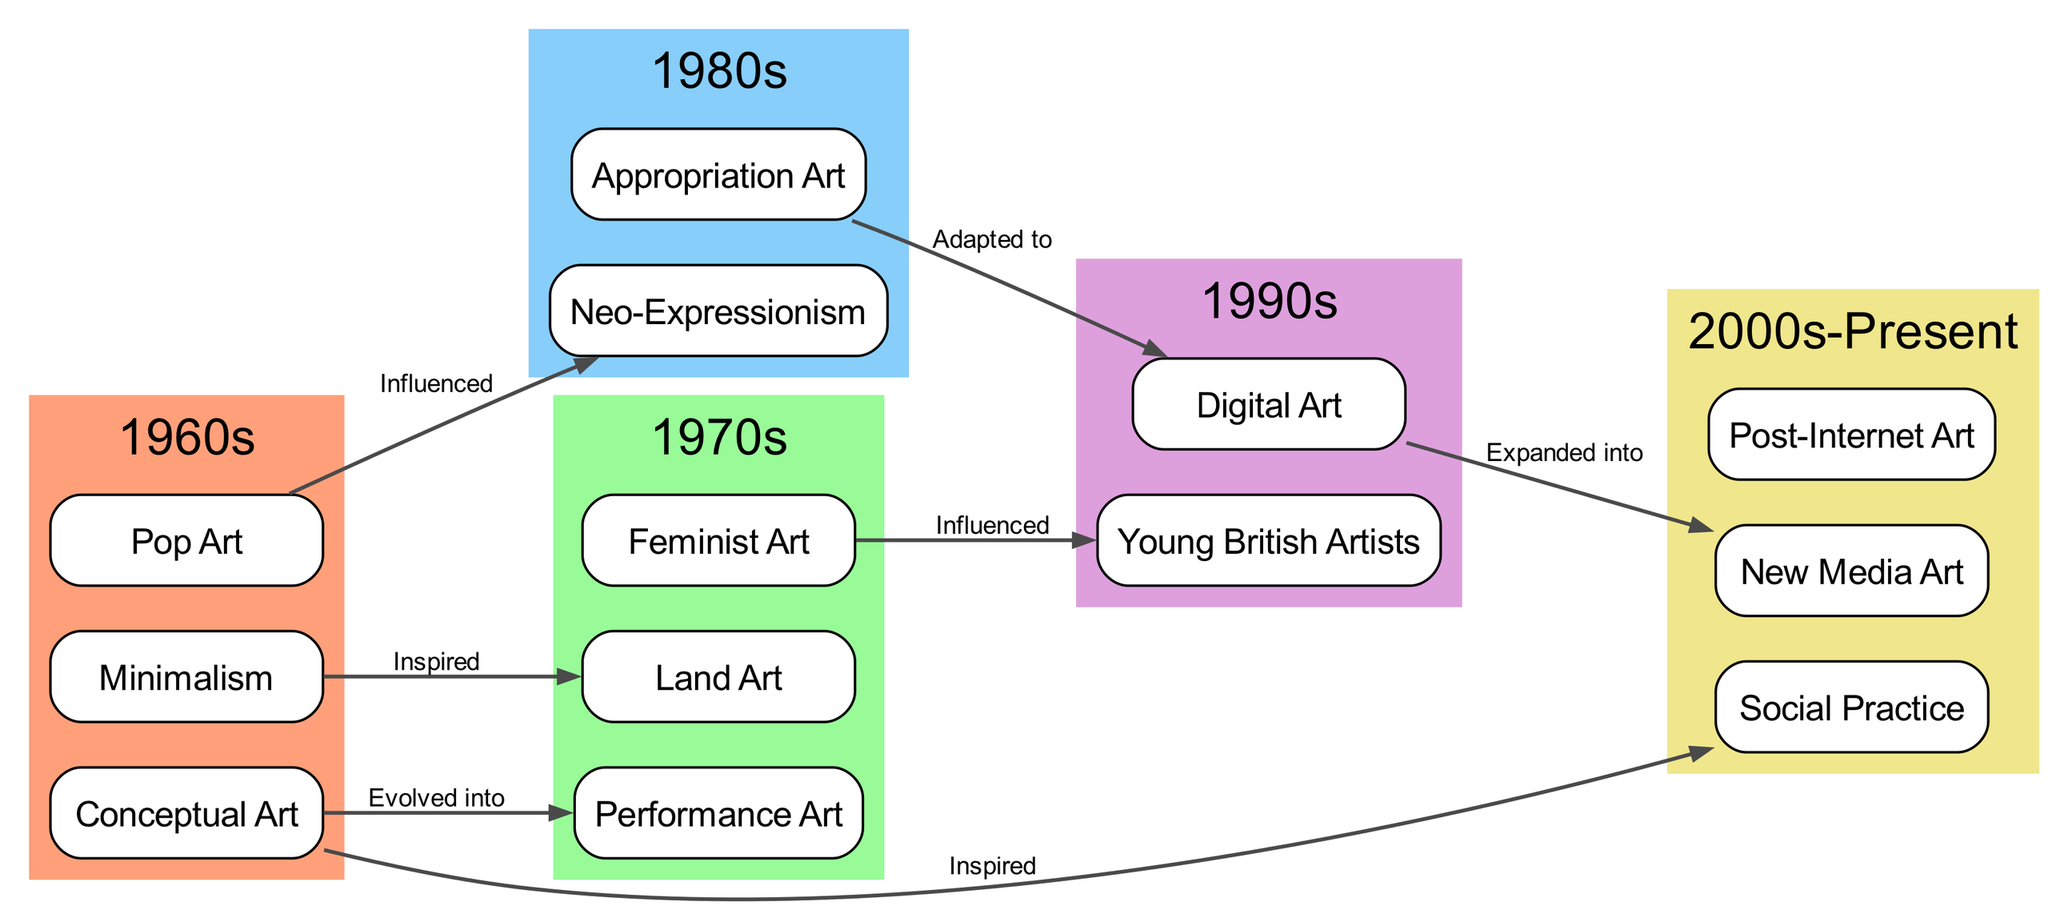What are the art movements listed under the 1970s? The art movements are found in the node labeled "1970s." The child nodes directly below it are "Performance Art," "Land Art," and "Feminist Art."
Answer: Performance Art, Land Art, Feminist Art Which movement evolved from Conceptual Art? The diagram indicates a direct relationship from the node "Conceptual Art" to "Performance Art" with the label "Evolved into." This means that Performance Art is identified as having evolved from Conceptual Art.
Answer: Performance Art How many edges are depicted in the diagram? To find the number of edges, one must count the connections listed in the edges section of the diagram. There are a total of 7 edges identified.
Answer: 7 Which movement was influenced by Pop Art? The diagram shows an edge originating from "Pop Art" and connecting to "Neo-Expressionism" with the label "Influenced." This indicates that Neo-Expressionism was influenced by Pop Art.
Answer: Neo-Expressionism What decade comes after the 1980s in the diagram? The nodes are structured chronologically. The node "1990s" directly follows the node "1980s," indicating that this is the next decade in the evolution of contemporary art movements.
Answer: 1990s How is Digital Art connected to Appropriation Art? According to the edge in the diagram, there is a relationship between "Appropriation Art" and "Digital Art," labeled "Adapted to." This indicates that Digital Art adapts elements from Appropriation Art.
Answer: Adapted to Which art movement directly influenced Young British Artists? The diagram indicates that "Feminist Art" has an influence on "Young British Artists," as depicted by the labeled edge connecting the two.
Answer: Feminist Art What are the three movements listed under the 2000s-Present? The movements under the node labeled "2000s-Present" include "Social Practice," "New Media Art," and "Post-Internet Art." These are the current movements included in this timeframe.
Answer: Social Practice, New Media Art, Post-Internet Art What movement is inspired by Minimalism? The connection from "Minimalism" to "Land Art" is marked with the label "Inspired," showing that Land Art draws inspiration from Minimalism. Hence, Land Art is the answer to the question.
Answer: Land Art 